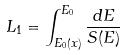<formula> <loc_0><loc_0><loc_500><loc_500>L _ { 1 } = \int _ { E _ { 0 } ( x ) } ^ { E _ { 0 } } \frac { d E } { S ( E ) }</formula> 